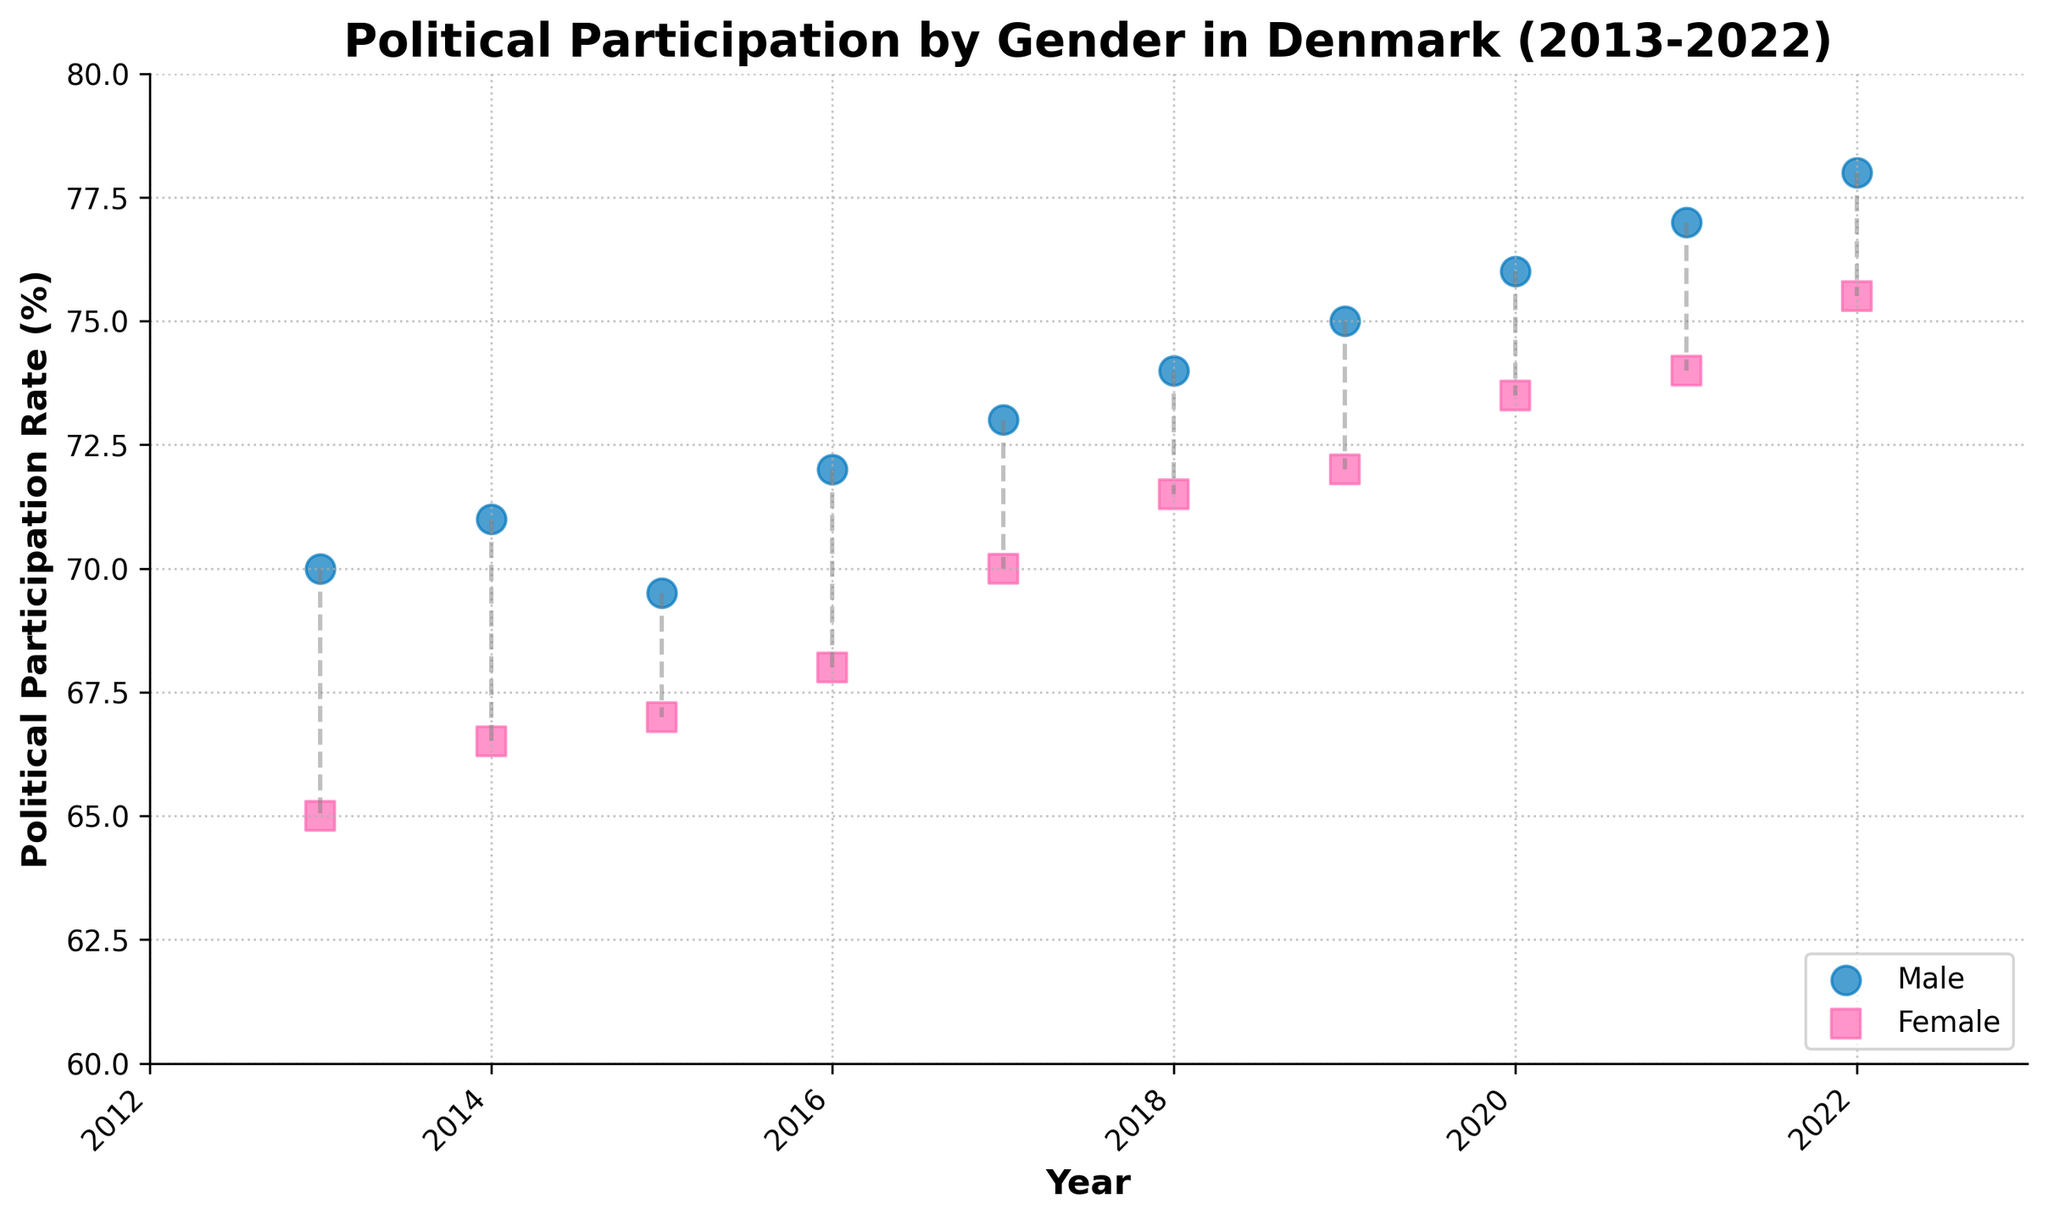What's the title of the scatter plot? The title of the scatter plot is mentioned at the top of the figure.
Answer: Political Participation by Gender in Denmark (2013-2022) How many years are represented in the scatter plot? Counting the data points along the x-axis, we see the years from 2013 to 2022, which means there are 10 years.
Answer: 10 Which gender had a higher participation rate in 2018? Look at the scatter points for 2018; the blue dots represent males, and the pink squares represent females. The male participation rate is higher.
Answer: Male What's the political participation rate for both genders in 2020? Refer to the scatter points for the year 2020. The blue dot (male) is at 76%, and the pink square (female) is at 73.5%.
Answer: Male: 76%, Female: 73.5% By how much did the political participation rate for females increase from 2013 to 2022? Identify the political participation rates for females in 2013 (65%) and 2022 (75.5%). The increase is calculated as 75.5% - 65%.
Answer: 10.5% What's the difference in participation rates between males and females in 2017? The scatter points for 2017 show a male participation rate of 73% and a female rate of 70%. The difference is 73% - 70%.
Answer: 3% In which year is the gender gap (difference in participation rate) the smallest? Examine the difference in participation rates for each year. The smallest gap is in 2015 with a difference of 2.5% (69.5% - 67%).
Answer: 2015 What trend can you observe about political participation rates over time for both genders? Both scatter points for each gender show an increasing trend over the years from 2013 to 2022.
Answer: Increasing What's the average participation rate for males across the decade? Sum the male participation rates for all years and divide by the number of years (10). (70 + 71 + 69.5 + 72 + 73 + 74 + 75 + 76 + 77 + 78) / 10 = 73.45%.
Answer: 73.45% Compare the political participation in 2013 and 2022 for both genders. Has the gap become wider or narrower? In 2013, the gap was 5% (70% - 65%), and in 2022, the gap is 2.5% (78% - 75.5%). The gap has narrowed over the decade.
Answer: Narrower 